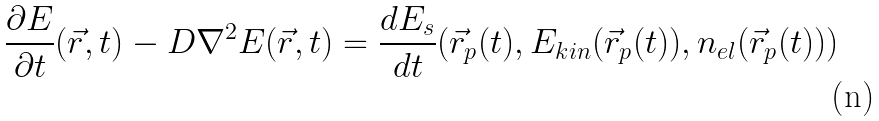Convert formula to latex. <formula><loc_0><loc_0><loc_500><loc_500>\frac { \partial E } { \partial t } ( \vec { r } , t ) - D \nabla ^ { 2 } E ( \vec { r } , t ) = \frac { d E _ { s } } { d t } ( \vec { r } _ { p } ( t ) , E _ { k i n } ( \vec { r } _ { p } ( t ) ) , n _ { e l } ( \vec { r } _ { p } ( t ) ) )</formula> 